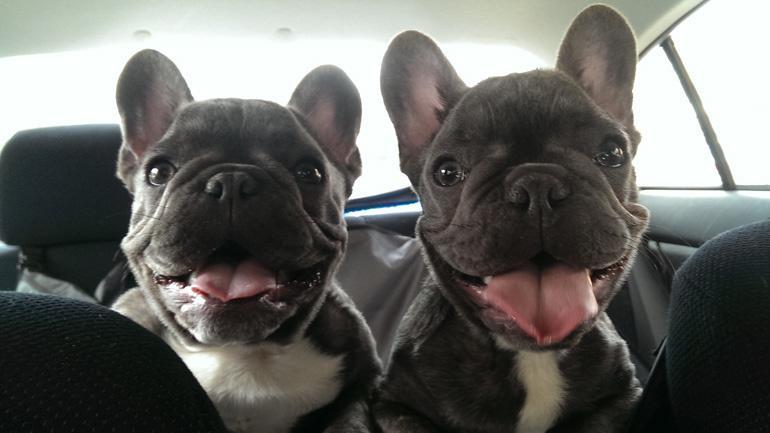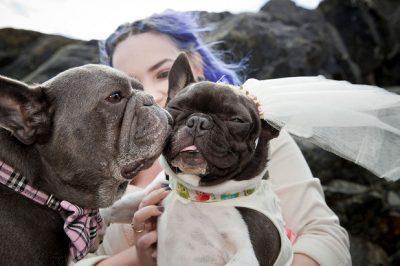The first image is the image on the left, the second image is the image on the right. For the images shown, is this caption "An image shows two tan big-eared dogs posed alongside each other on a seat cushion with a burlap-like rough woven texture." true? Answer yes or no. No. The first image is the image on the left, the second image is the image on the right. Given the left and right images, does the statement "There are two dogs with mouths open and tongue visible in the left image." hold true? Answer yes or no. Yes. 